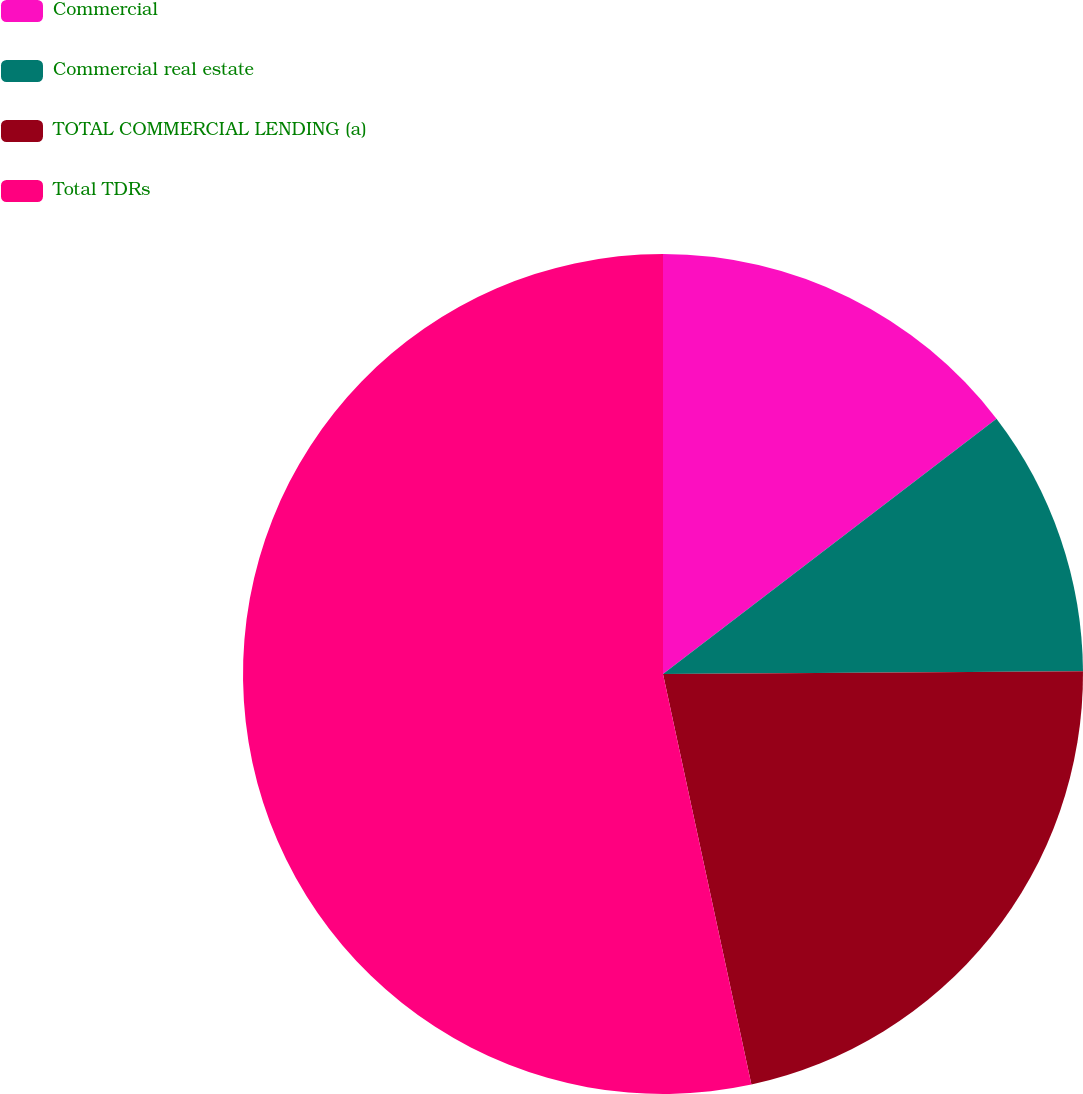<chart> <loc_0><loc_0><loc_500><loc_500><pie_chart><fcel>Commercial<fcel>Commercial real estate<fcel>TOTAL COMMERCIAL LENDING (a)<fcel>Total TDRs<nl><fcel>14.6%<fcel>10.29%<fcel>21.73%<fcel>53.37%<nl></chart> 